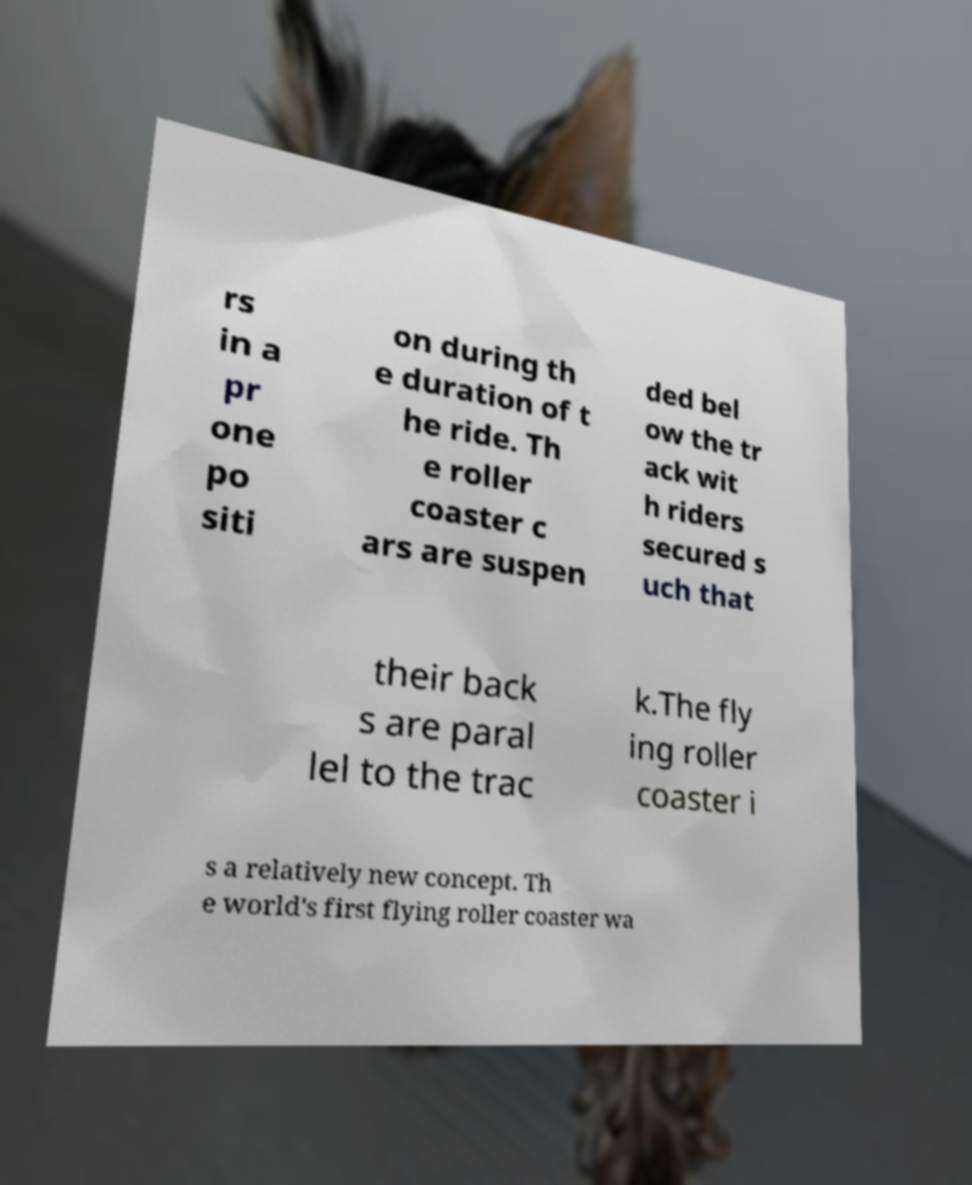Please identify and transcribe the text found in this image. rs in a pr one po siti on during th e duration of t he ride. Th e roller coaster c ars are suspen ded bel ow the tr ack wit h riders secured s uch that their back s are paral lel to the trac k.The fly ing roller coaster i s a relatively new concept. Th e world's first flying roller coaster wa 